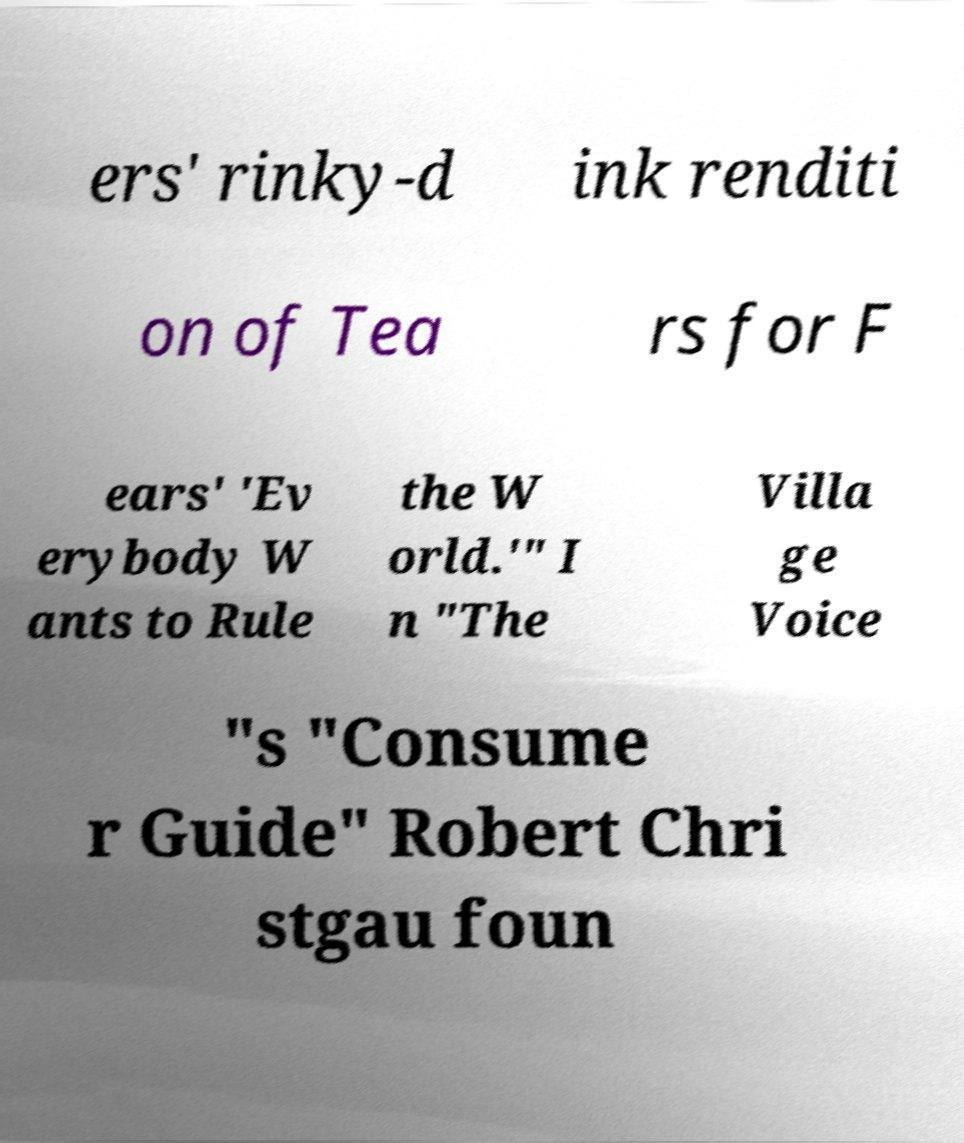Please identify and transcribe the text found in this image. ers' rinky-d ink renditi on of Tea rs for F ears' 'Ev erybody W ants to Rule the W orld.'" I n "The Villa ge Voice "s "Consume r Guide" Robert Chri stgau foun 